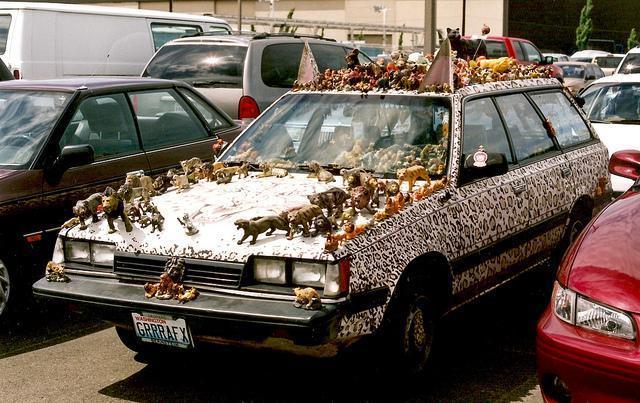How many red vehicles do you see?
Give a very brief answer. 2. How many trucks are there?
Give a very brief answer. 2. How many cars can be seen?
Give a very brief answer. 6. How many black birds are sitting on the curved portion of the stone archway?
Give a very brief answer. 0. 